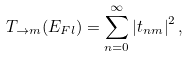<formula> <loc_0><loc_0><loc_500><loc_500>T _ { \rightarrow m } ( E _ { F l } ) = \sum _ { n = 0 } ^ { \infty } \left | { t } _ { n m } \right | ^ { 2 } ,</formula> 